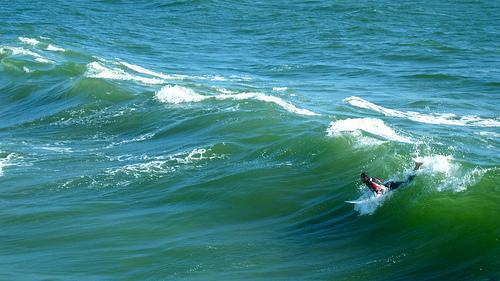How many people are in the picture?
Give a very brief answer. 1. How many people are surfing?
Give a very brief answer. 1. How many surfboards are there?
Give a very brief answer. 1. How many people are lying on a surfboard?
Give a very brief answer. 1. 